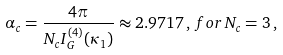Convert formula to latex. <formula><loc_0><loc_0><loc_500><loc_500>\alpha _ { c } = \frac { 4 \pi } { N _ { c } I _ { G } ^ { ( 4 ) } ( \kappa _ { 1 } ) } \approx 2 . 9 7 1 7 \, , \, f o r \, N _ { c } = 3 \, ,</formula> 